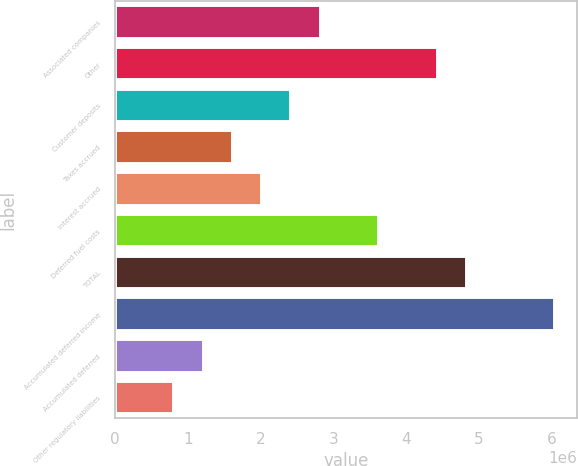Convert chart to OTSL. <chart><loc_0><loc_0><loc_500><loc_500><bar_chart><fcel>Associated companies<fcel>Other<fcel>Customer deposits<fcel>Taxes accrued<fcel>Interest accrued<fcel>Deferred fuel costs<fcel>TOTAL<fcel>Accumulated deferred income<fcel>Accumulated deferred<fcel>Other regulatory liabilities<nl><fcel>2.8251e+06<fcel>4.43574e+06<fcel>2.42244e+06<fcel>1.61711e+06<fcel>2.01978e+06<fcel>3.63042e+06<fcel>4.8384e+06<fcel>6.04639e+06<fcel>1.21445e+06<fcel>811792<nl></chart> 